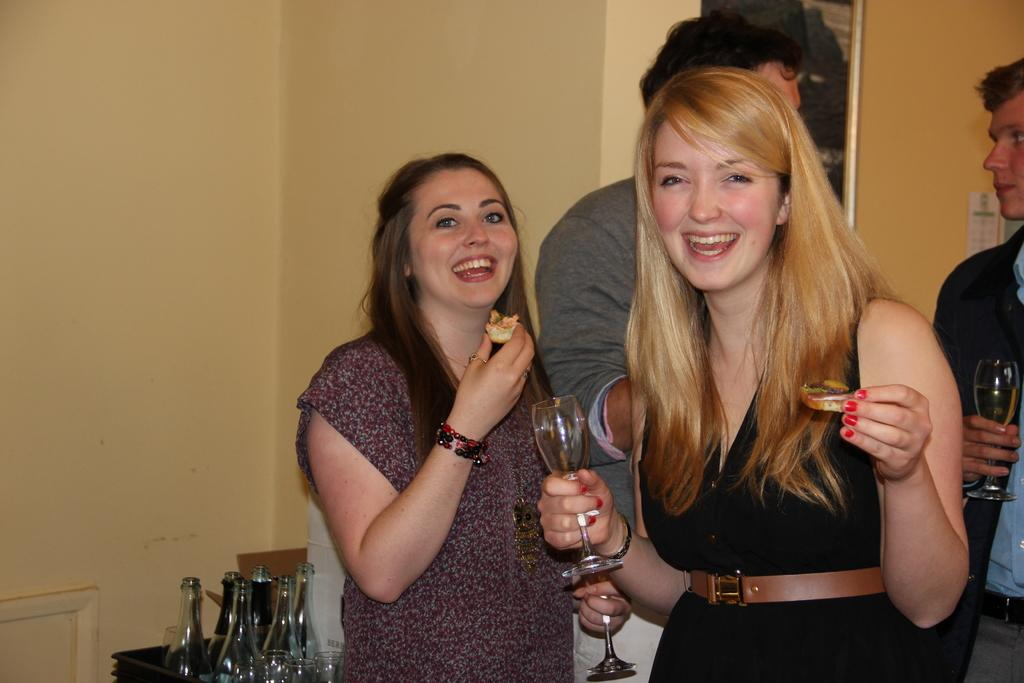How many women are in the image? There are two women in the image. What are the women doing in the image? The women are laughing. Can you describe the people in the background? There are two persons in the background, and they are speaking. What type of sound can be heard coming from the crook in the image? There is no crook present in the image, so it's not possible to determine what, if any, sound might be heard. 